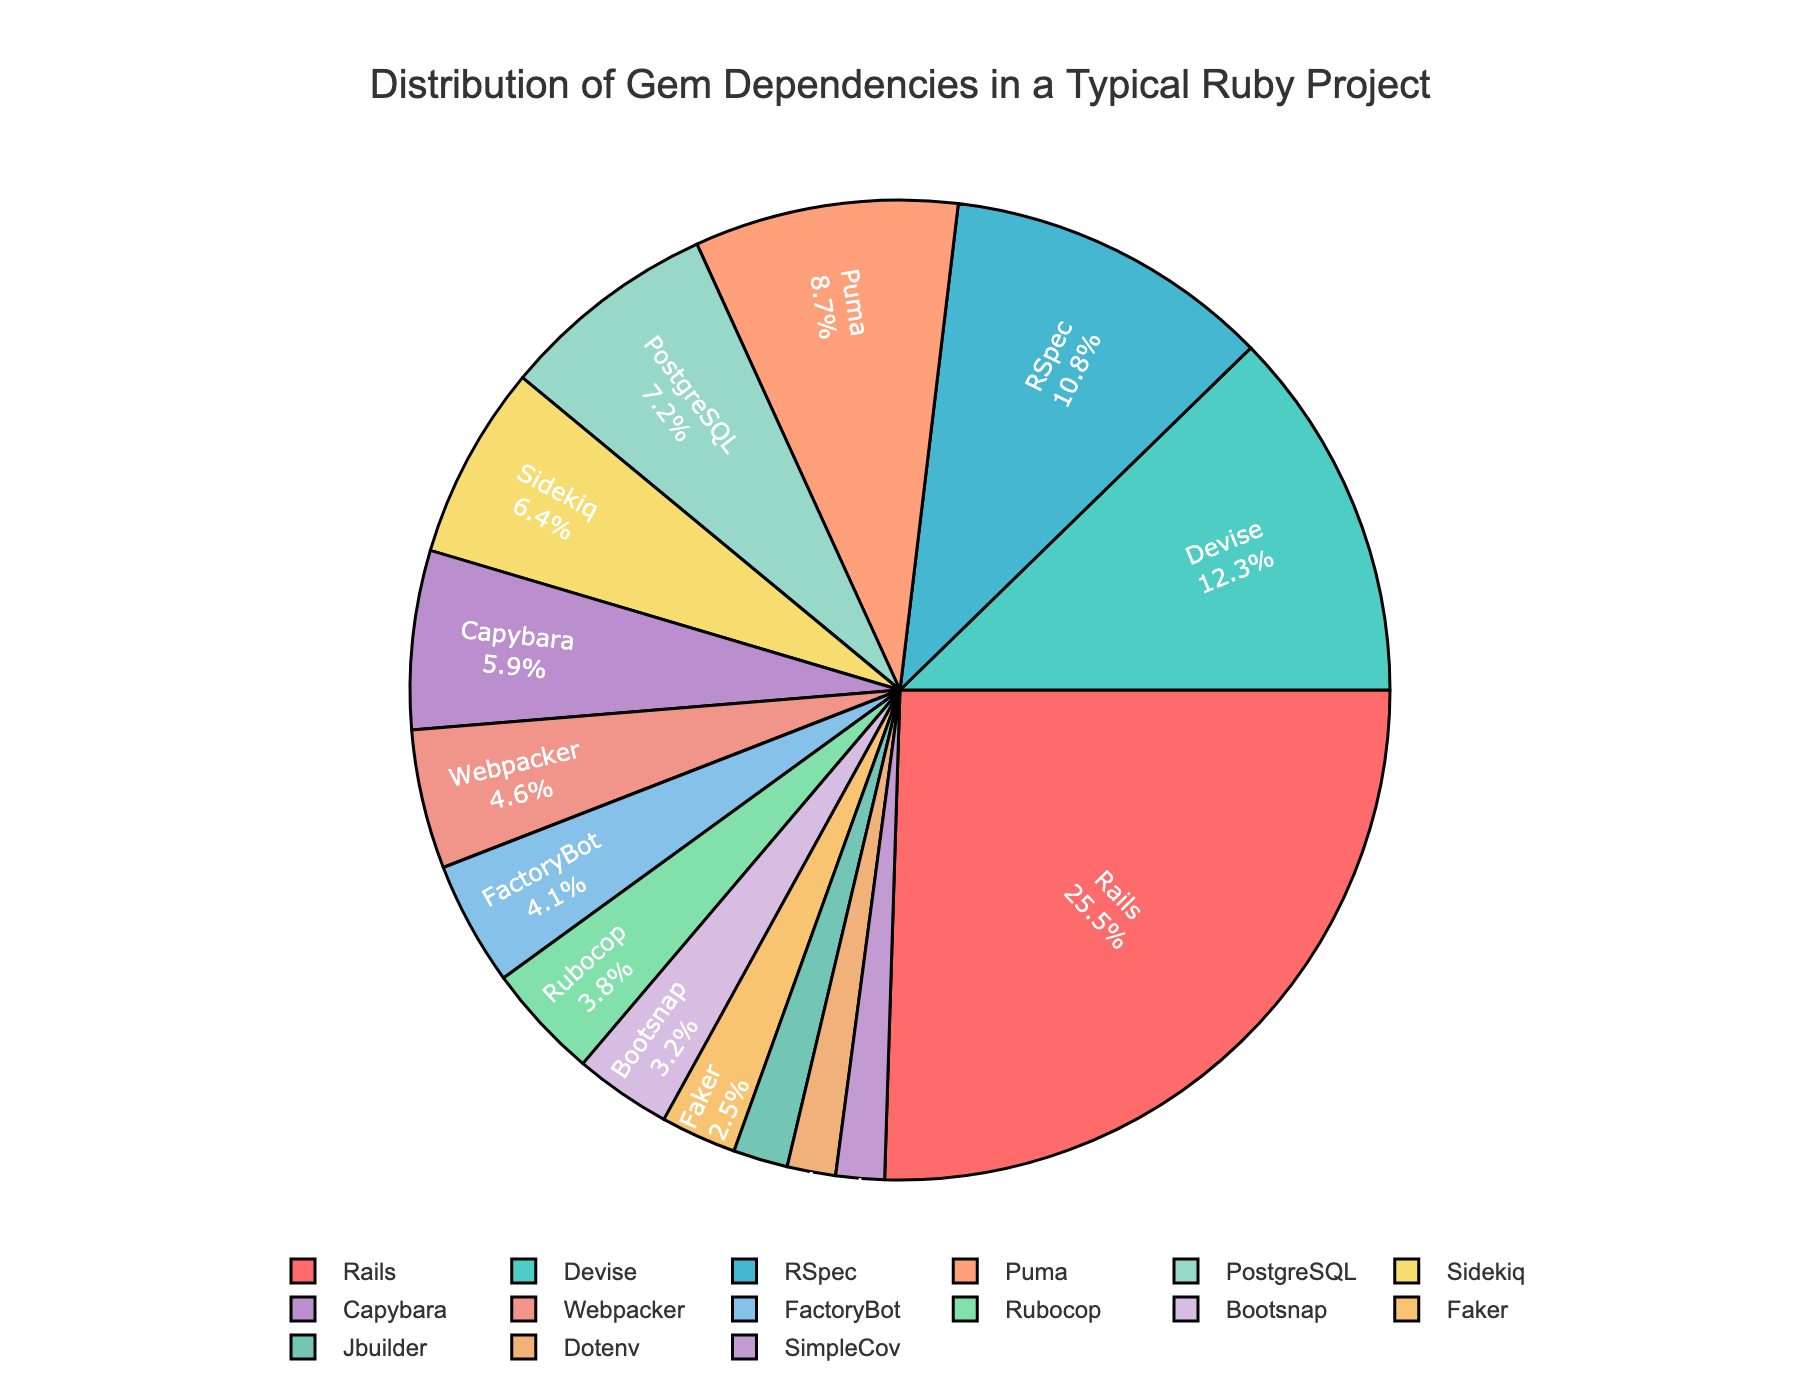What percentage of the total dependencies is contributed by Rails and Devise combined? To get the combined percentage for Rails and Devise, simply add their individual percentages: Rails (25.5%) + Devise (12.3%) = 37.8%
Answer: 37.8% Which gem shows a higher percentage, RSpec or Puma? Compare the percentages of RSpec (10.8%) and Puma (8.7%). RSpec has a higher percentage.
Answer: RSpec How many gems have a percentage greater than 5%? Identify gems with percentages greater than 5%: Rails (25.5%), Devise (12.3%), RSpec (10.8%), Puma (8.7%), PostgreSQL (7.2%), Sidekiq (6.4%), Capybara (5.9%). This totals 7 gems.
Answer: 7 Which gem has the smallest share in the pie chart, and what is its percentage? Look for the gem with the smallest percentage: Jbuilder (1.8%) and Dotenv (1.6%) & SimpleCov (1.6%). Sort these three and find Dotenv and SimpleCov have the smallest share.
Answer: Dotenv & SimpleCov, 1.6% By how much percentage does Rails exceed the combined percentage of Webpacker and FactoryBot? First, find the combined percentage of Webpacker (4.6%) + FactoryBot (4.1%) = 8.7%. Then, subtract this from Rails' percentage: 25.5% - 8.7% = 16.8%.
Answer: 16.8% Do any gems have the same share of dependencies, and if so, which ones? Identify any duplicates in the percentages: Jbuilder (1.8%), Dotenv (1.6%), SimpleCov (1.6%). Dotenv and SimpleCov have the same share at 1.6%.
Answer: Dotenv & SimpleCov What's the combined share of PostgreSQL, Sidekiq, and Capybara? Add the percentages for PostgreSQL (7.2%), Sidekiq (6.4%), and Capybara (5.9%): 7.2% + 6.4% + 5.9% = 19.5%.
Answer: 19.5% Which color represents the Rails dependency? The pie chart legend indicates that colors are assigned in the order listed: Rails being the first is represented by the first color, red.
Answer: Red 